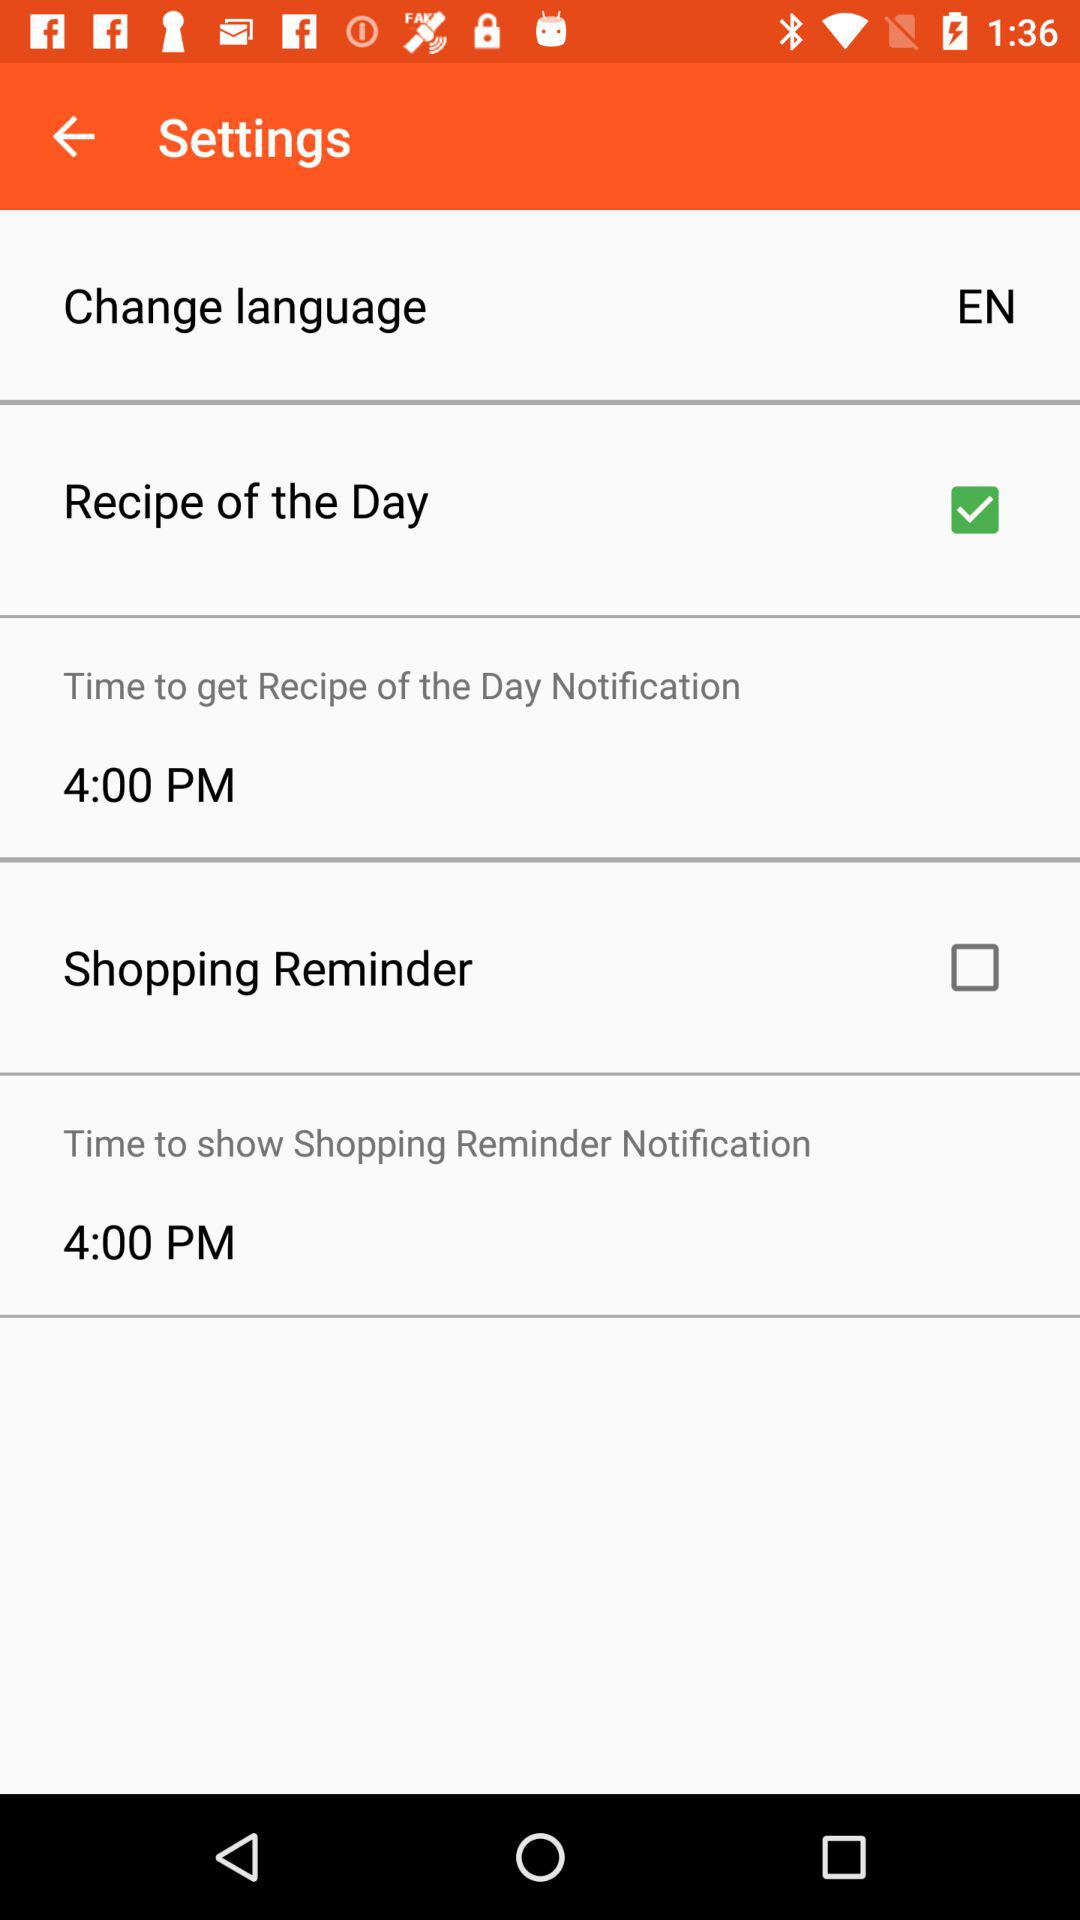What is the current status of the "Shopping Reminder"? The current status of the "Shopping Reminder" is "off". 